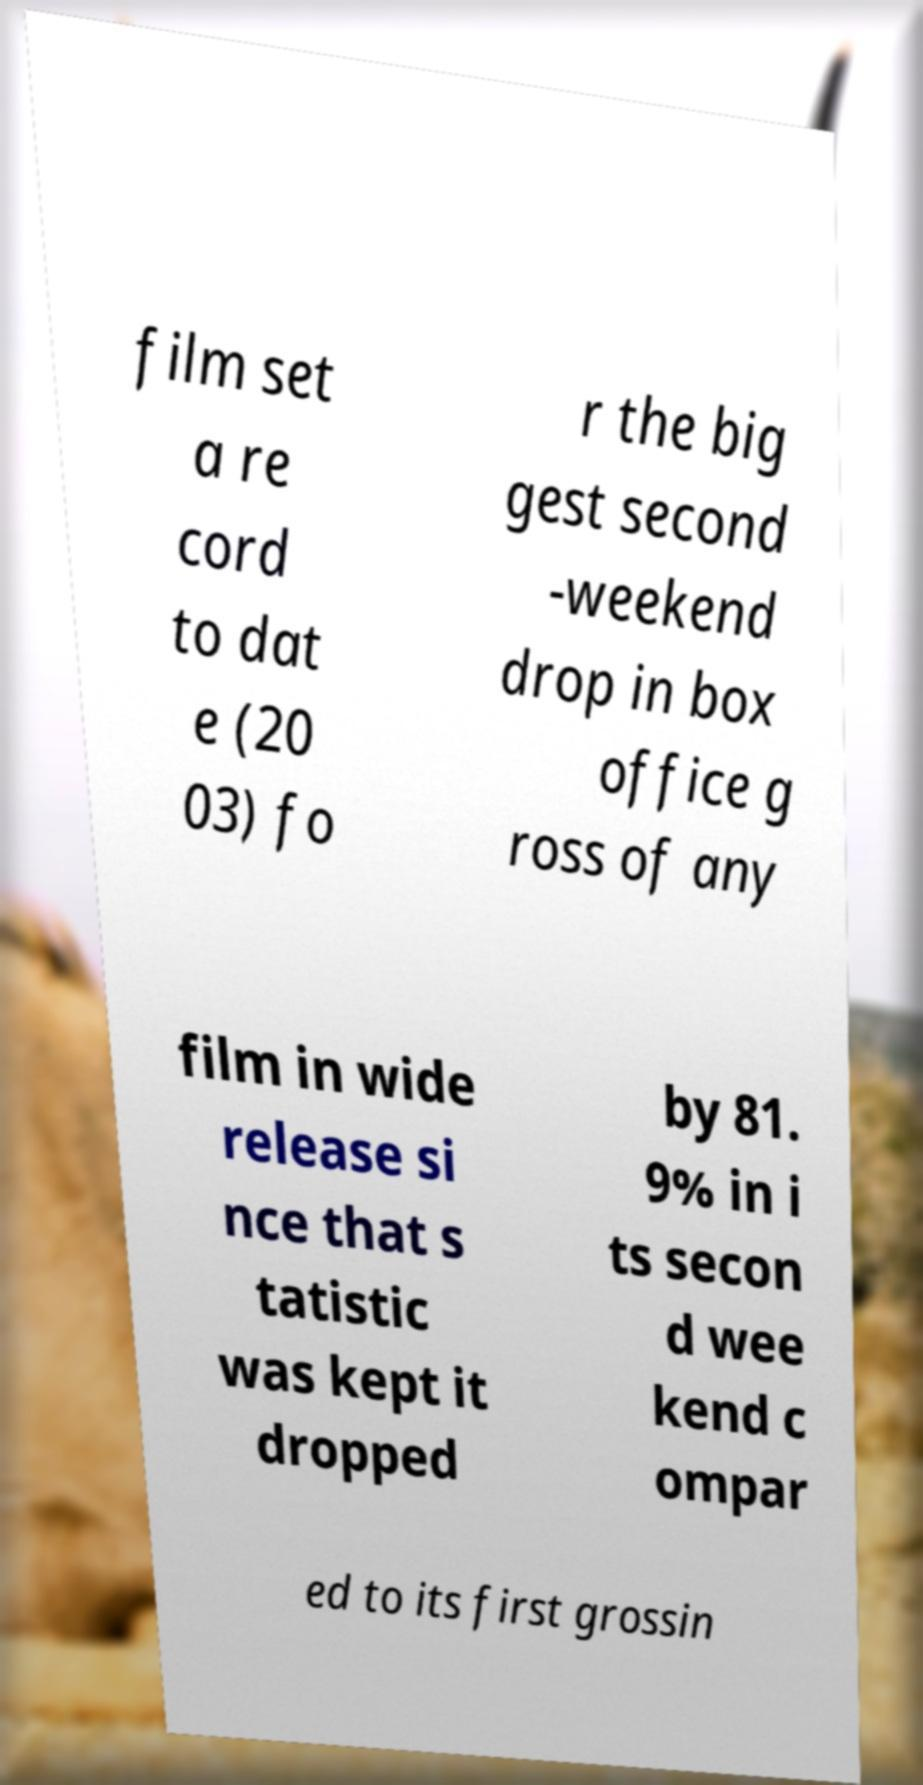For documentation purposes, I need the text within this image transcribed. Could you provide that? film set a re cord to dat e (20 03) fo r the big gest second -weekend drop in box office g ross of any film in wide release si nce that s tatistic was kept it dropped by 81. 9% in i ts secon d wee kend c ompar ed to its first grossin 